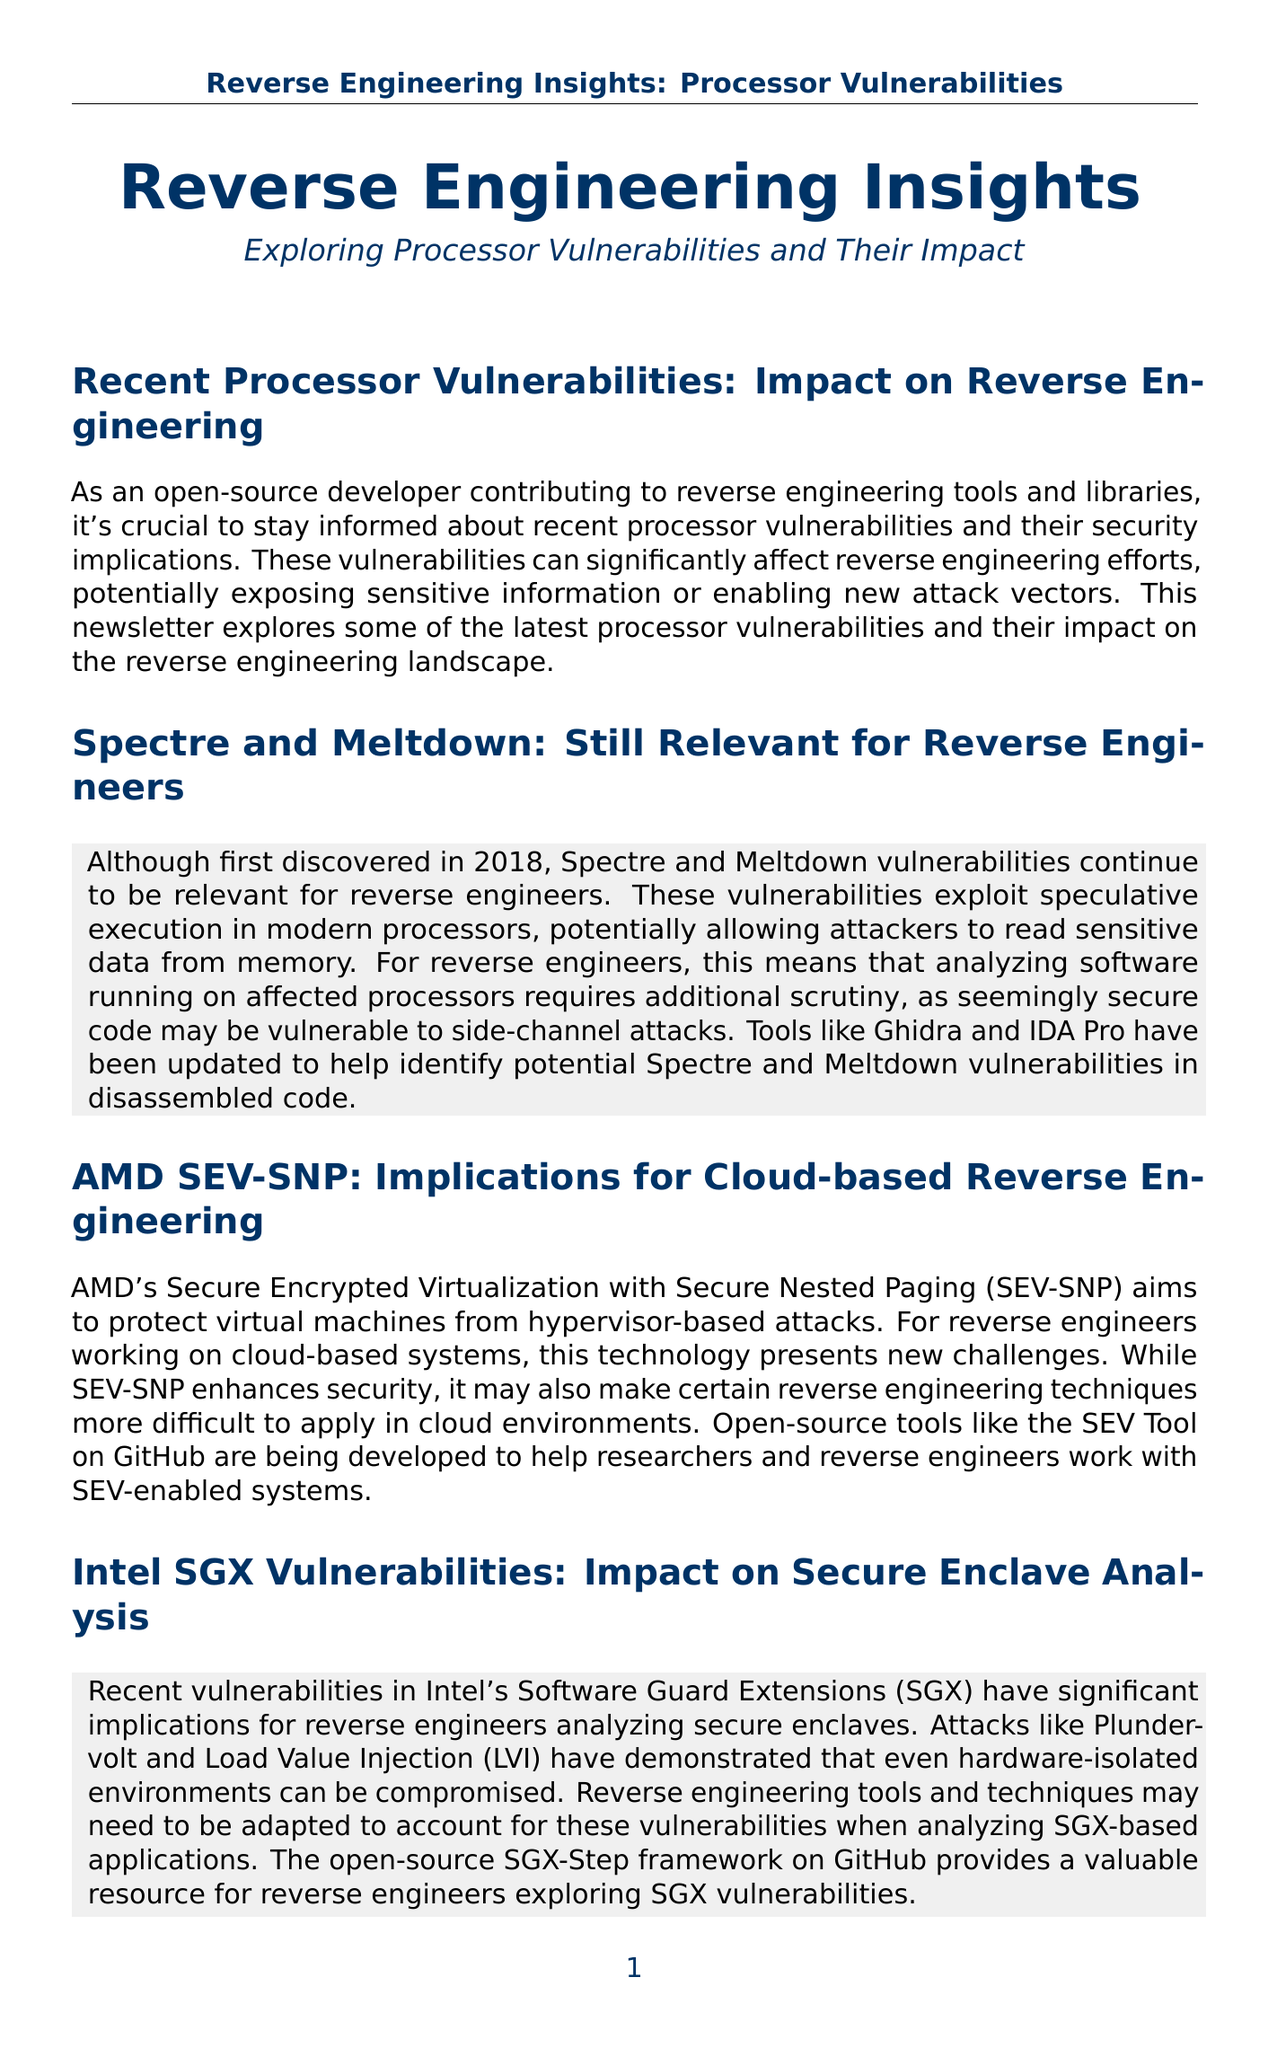What are the two processor vulnerabilities originally discovered in 2018? The document mentions Spectre and Meltdown as the two processor vulnerabilities discovered in 2018.
Answer: Spectre and Meltdown What does AMD SEV-SNP aim to protect against? The document states that AMD SEV-SNP aims to protect virtual machines from hypervisor-based attacks.
Answer: Hypervisor-based attacks Which reverse engineering tool has been updated to help identify Spectre and Meltdown vulnerabilities? The document lists Ghidra and IDA Pro as tools that have been updated for this purpose.
Answer: Ghidra and IDA Pro What kind of attacks have demonstrated vulnerabilities in Intel SGX? The document mentions Plundervolt and Load Value Injection (LVI) as attacks affecting Intel SGX vulnerabilities.
Answer: Plundervolt and Load Value Injection What challenge does RISC-V present to reverse engineers? The document indicates that dealing with custom extensions introduces new challenges for reverse engineers using RISC-V.
Answer: Custom extensions What is the impact of side-channel attacks on reverse engineering? The document suggests that side-channel attacks can expose sensitive information or enable new attack vectors, affecting reverse engineering efforts.
Answer: Expose sensitive information or enable new attack vectors What open-source project is mentioned as a resource for side-channel attack implementation? The document references the Keyboard Sniffer project as providing insights for reverse engineers regarding side-channel attacks.
Answer: Keyboard Sniffer What is the main objective of the newsletter? The newsletter aims to explore processor vulnerabilities and their impact on reverse engineering efforts.
Answer: Explore processor vulnerabilities and their impact on reverse engineering efforts What importance is stressed in the conclusion section? The conclusion emphasizes the importance of staying informed about the latest processor vulnerabilities and their security implications.
Answer: Staying informed about the latest processor vulnerabilities and their security implications 